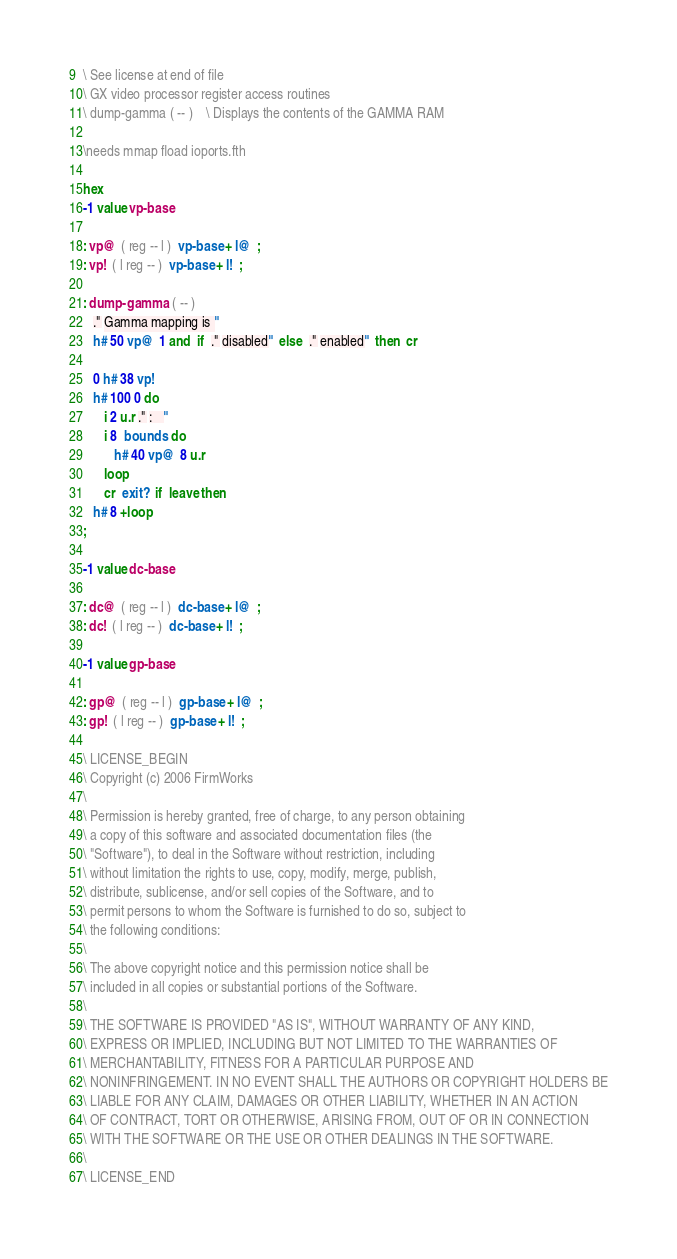<code> <loc_0><loc_0><loc_500><loc_500><_Forth_>\ See license at end of file
\ GX video processor register access routines
\ dump-gamma ( -- )    \ Displays the contents of the GAMMA RAM

\needs mmap fload ioports.fth

hex
-1 value vp-base

: vp@  ( reg -- l )  vp-base + l@  ;
: vp!  ( l reg -- )  vp-base + l!  ;

: dump-gamma  ( -- )
   ." Gamma mapping is "
   h# 50 vp@  1 and  if  ." disabled"  else  ." enabled"  then  cr

   0 h# 38 vp!
   h# 100 0 do
      i 2 u.r ." :   "
      i 8  bounds  do
         h# 40 vp@  8 u.r
      loop
      cr  exit?  if  leave then
   h# 8 +loop
;

-1 value dc-base

: dc@  ( reg -- l )  dc-base + l@  ;
: dc!  ( l reg -- )  dc-base + l!  ;

-1 value gp-base

: gp@  ( reg -- l )  gp-base + l@  ;
: gp!  ( l reg -- )  gp-base + l!  ;

\ LICENSE_BEGIN
\ Copyright (c) 2006 FirmWorks
\ 
\ Permission is hereby granted, free of charge, to any person obtaining
\ a copy of this software and associated documentation files (the
\ "Software"), to deal in the Software without restriction, including
\ without limitation the rights to use, copy, modify, merge, publish,
\ distribute, sublicense, and/or sell copies of the Software, and to
\ permit persons to whom the Software is furnished to do so, subject to
\ the following conditions:
\ 
\ The above copyright notice and this permission notice shall be
\ included in all copies or substantial portions of the Software.
\ 
\ THE SOFTWARE IS PROVIDED "AS IS", WITHOUT WARRANTY OF ANY KIND,
\ EXPRESS OR IMPLIED, INCLUDING BUT NOT LIMITED TO THE WARRANTIES OF
\ MERCHANTABILITY, FITNESS FOR A PARTICULAR PURPOSE AND
\ NONINFRINGEMENT. IN NO EVENT SHALL THE AUTHORS OR COPYRIGHT HOLDERS BE
\ LIABLE FOR ANY CLAIM, DAMAGES OR OTHER LIABILITY, WHETHER IN AN ACTION
\ OF CONTRACT, TORT OR OTHERWISE, ARISING FROM, OUT OF OR IN CONNECTION
\ WITH THE SOFTWARE OR THE USE OR OTHER DEALINGS IN THE SOFTWARE.
\
\ LICENSE_END
</code> 